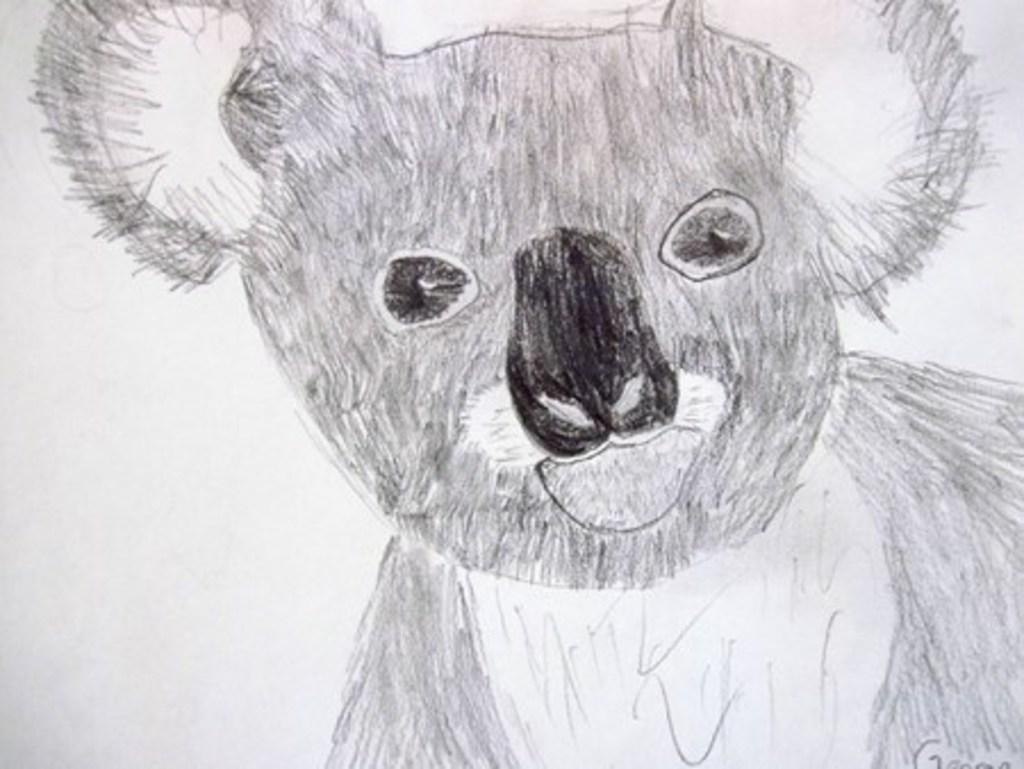What type of image is shown in the picture? The image is a drawing. What is the main subject of the drawing? The drawing depicts a teddy bear. What type of cart is visible in the drawing? There is no cart present in the drawing; it features a teddy bear. What kind of bird can be seen flying near the teddy bear in the drawing? There is no bird present in the drawing; it only features a teddy bear. 